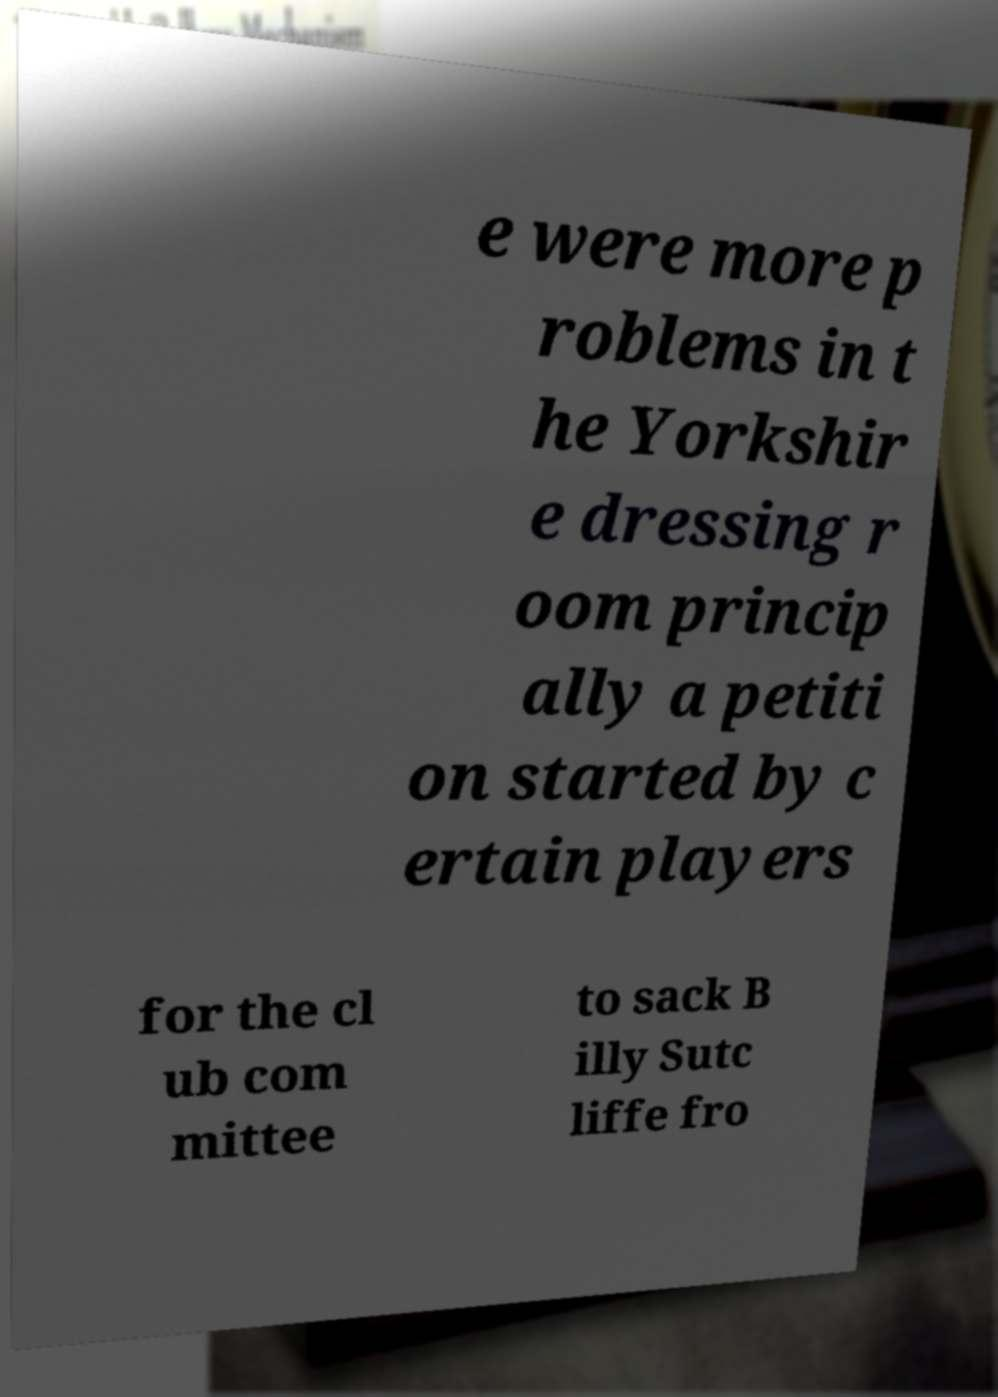Could you extract and type out the text from this image? e were more p roblems in t he Yorkshir e dressing r oom princip ally a petiti on started by c ertain players for the cl ub com mittee to sack B illy Sutc liffe fro 